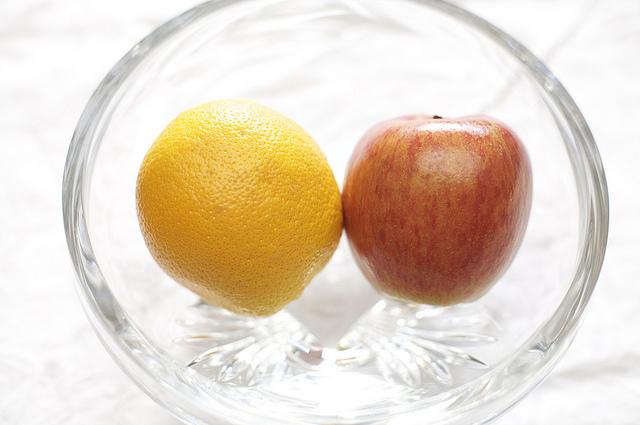Is the bowl blue?
Be succinct. No. What is the bowl made of?
Answer briefly. Glass. How many fruits are in the bowl?
Answer briefly. 2. 